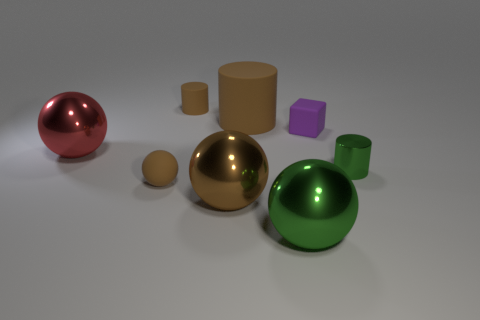Can you describe the lighting in the image? The lighting in the image is soft and diffused, which creates gentle shadows and suggests an indoor setting, possibly a studio environment. The way the light reflects off the objects indicates a single light source above the scene, simulating an overhead light. This setup highlights the objects' shapes and textures while avoiding harsh glare. How does the lighting affect the appearance of the objects? The diffused lighting helps to enhance the three-dimensional form of each object, giving depth to the scene. It also creates subtle shadows that provide clues about the relative positioning and sizes of the objects. The reflective surfaces of the metallic-looking objects capture and reflect the light, giving them a luminous quality, while the matte surfaces absorb the light, giving a soft appearance. 